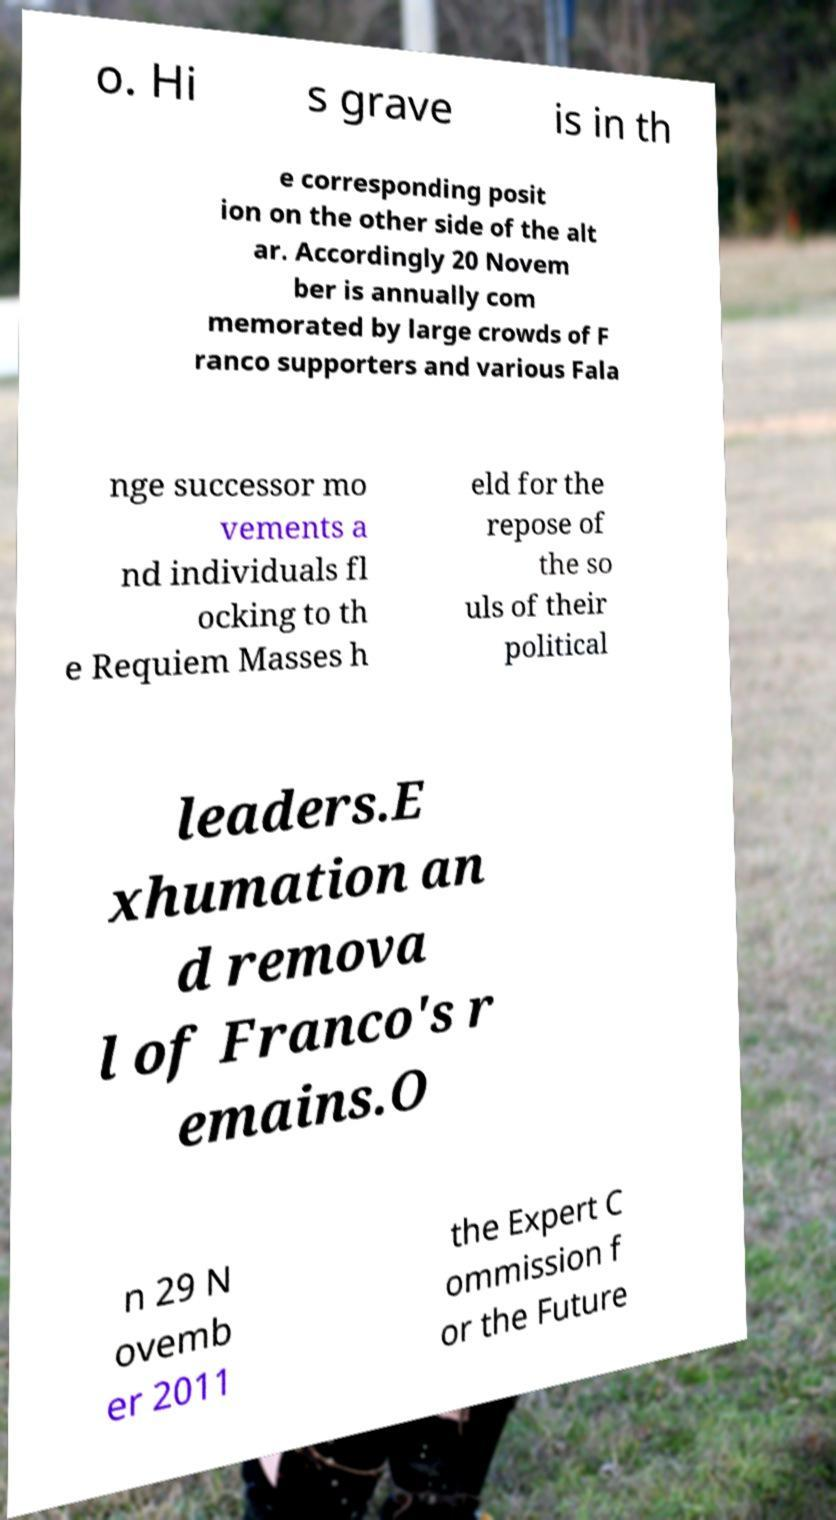Can you accurately transcribe the text from the provided image for me? o. Hi s grave is in th e corresponding posit ion on the other side of the alt ar. Accordingly 20 Novem ber is annually com memorated by large crowds of F ranco supporters and various Fala nge successor mo vements a nd individuals fl ocking to th e Requiem Masses h eld for the repose of the so uls of their political leaders.E xhumation an d remova l of Franco's r emains.O n 29 N ovemb er 2011 the Expert C ommission f or the Future 